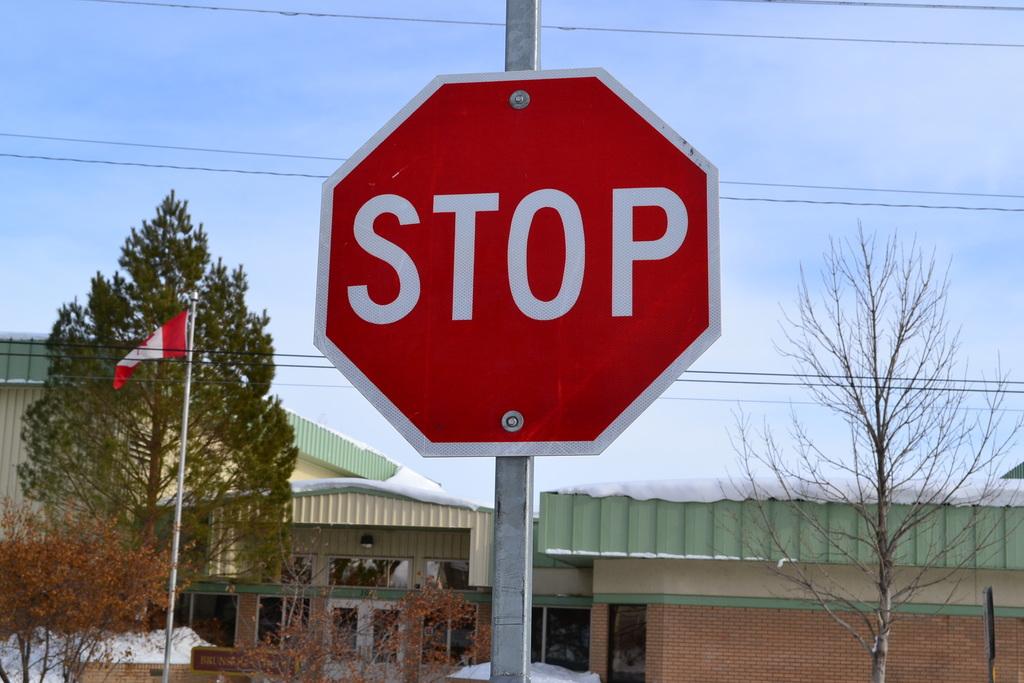What kind of street sign is this?
Make the answer very short. Stop. What does the sign say?
Give a very brief answer. Stop. 